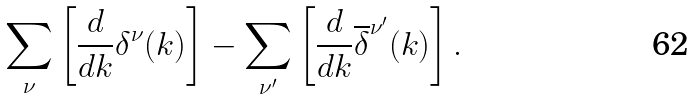<formula> <loc_0><loc_0><loc_500><loc_500>\sum _ { \nu } \left [ \frac { d } { d k } \delta ^ { \nu } ( k ) \right ] - \sum _ { \nu ^ { \prime } } \left [ \frac { d } { d k } \overline { \delta } ^ { \nu ^ { \prime } } ( k ) \right ] .</formula> 